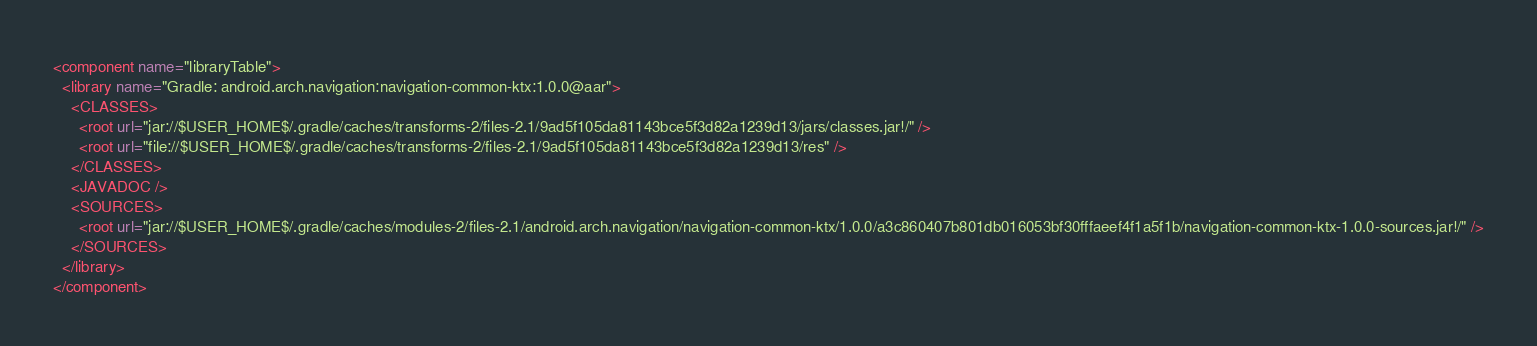<code> <loc_0><loc_0><loc_500><loc_500><_XML_><component name="libraryTable">
  <library name="Gradle: android.arch.navigation:navigation-common-ktx:1.0.0@aar">
    <CLASSES>
      <root url="jar://$USER_HOME$/.gradle/caches/transforms-2/files-2.1/9ad5f105da81143bce5f3d82a1239d13/jars/classes.jar!/" />
      <root url="file://$USER_HOME$/.gradle/caches/transforms-2/files-2.1/9ad5f105da81143bce5f3d82a1239d13/res" />
    </CLASSES>
    <JAVADOC />
    <SOURCES>
      <root url="jar://$USER_HOME$/.gradle/caches/modules-2/files-2.1/android.arch.navigation/navigation-common-ktx/1.0.0/a3c860407b801db016053bf30fffaeef4f1a5f1b/navigation-common-ktx-1.0.0-sources.jar!/" />
    </SOURCES>
  </library>
</component></code> 